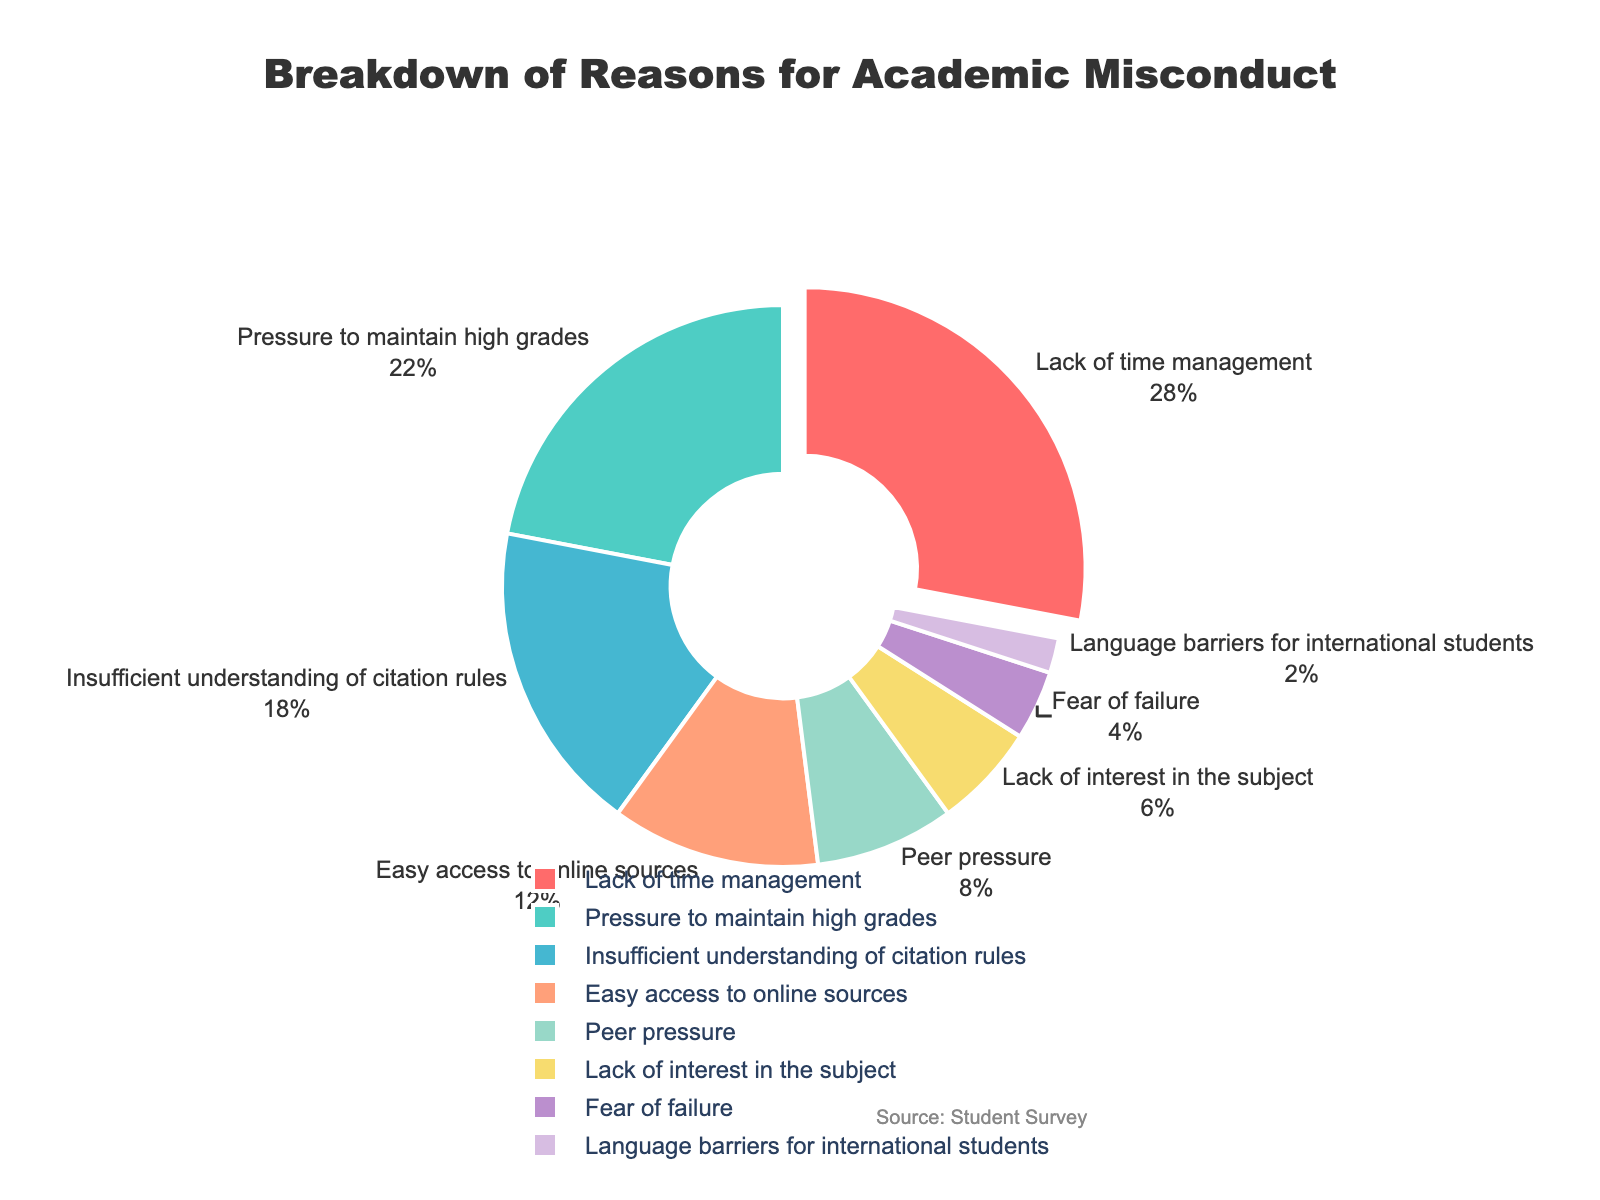What is the most commonly reported reason for academic misconduct? The most commonly reported reason is the segment pulled out from the pie chart and has the highest percentage value. It is labelled "Lack of time management" with a percentage of 28%.
Answer: Lack of time management Which color represents the cause with the second-highest percentage? By referring to the color associated with the label "Pressure to maintain high grades," which has a percentage of 22%, we can see it is represented by a greenish-blue color.
Answer: Greenish-blue What is the total percentage of reasons related to student pressures (Pressure to maintain high grades and Peer pressure)? Sum the percentages for "Pressure to maintain high grades" (22%) and "Peer pressure" (8%). 22 + 8 = 30%.
Answer: 30% How many reasons have a percentage value below 10%? The reasons listed are "Peer pressure" (8%), "Lack of interest in the subject" (6%), "Fear of failure" (4%), and "Language barriers for international students" (2%). This makes a total of 4 reasons.
Answer: 4 Which reason has the smallest percentage, and how much is it? The smallest percentage has the smallest slice in the chart. It is labelled "Language barriers for international students," which has a percentage value of 2%.
Answer: Language barriers for international students, 2% What is the combined percentage of "Easy access to online sources" and "Insufficient understanding of citation rules"? Sum the percentages for "Easy access to online sources" (12%) and "Insufficient understanding of citation rules" (18%). 12 + 18 = 30%.
Answer: 30% Which reason is represented by the yellow segment on the pie chart? The yellow segment corresponds to the label "Lack of interest in the subject" with a percentage of 6%.
Answer: Lack of interest in the subject Is the percentage of "Fear of failure" greater than "Language barriers for international students"? Compare the percentages for "Fear of failure" (4%) and "Language barriers for international students" (2%). Since 4% is greater than 2%, the answer is yes.
Answer: Yes What is the difference in percentage between "Lack of time management" and "Insufficient understanding of citation rules"? Subtract the percentage for "Insufficient understanding of citation rules" (18%) from "Lack of time management" (28%). 28 - 18 = 10%.
Answer: 10% Among the reasons listed, which one is tied to the highest percentage but not the top-most contributing factor? The top-most contributing factor is "Lack of time management" with 28%. The next highest is "Pressure to maintain high grades" with 22%.
Answer: Pressure to maintain high grades 